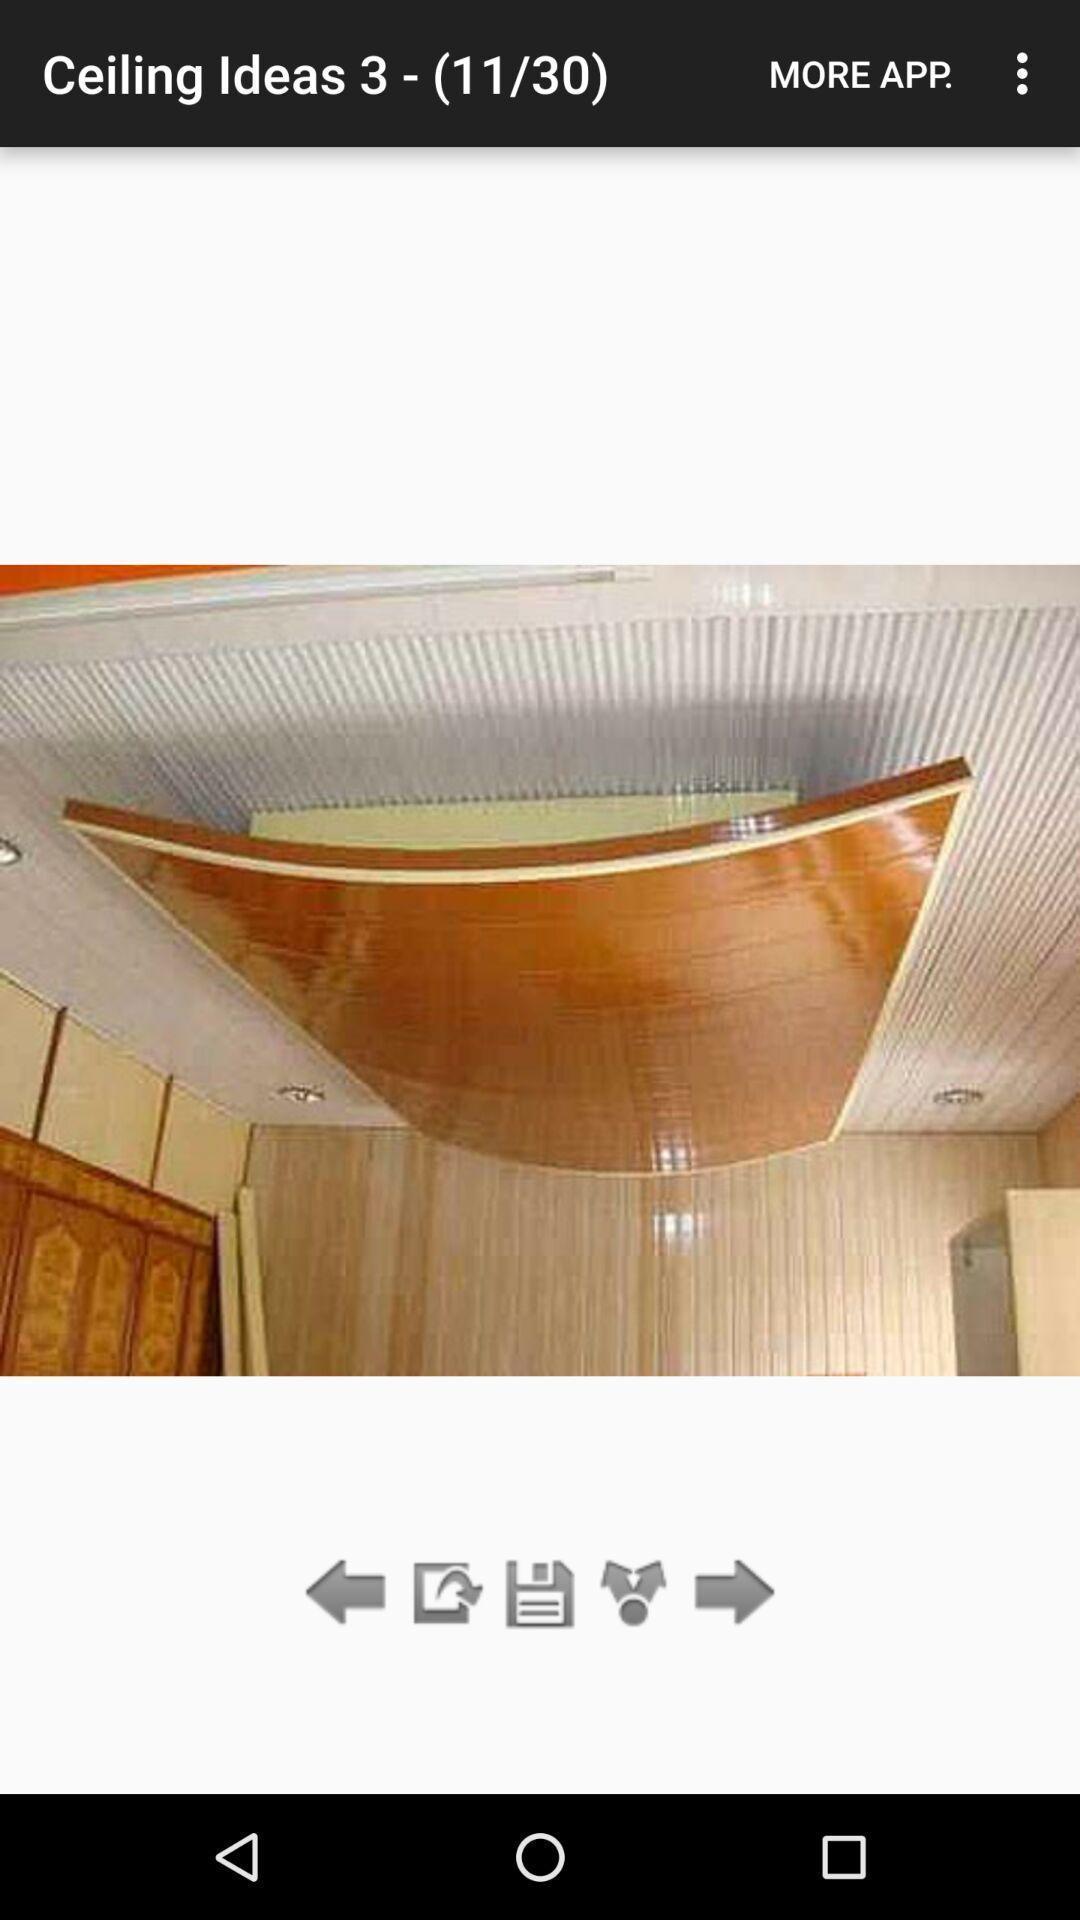Provide a textual representation of this image. Screen showing a picture of ceiling decorated on an app. 